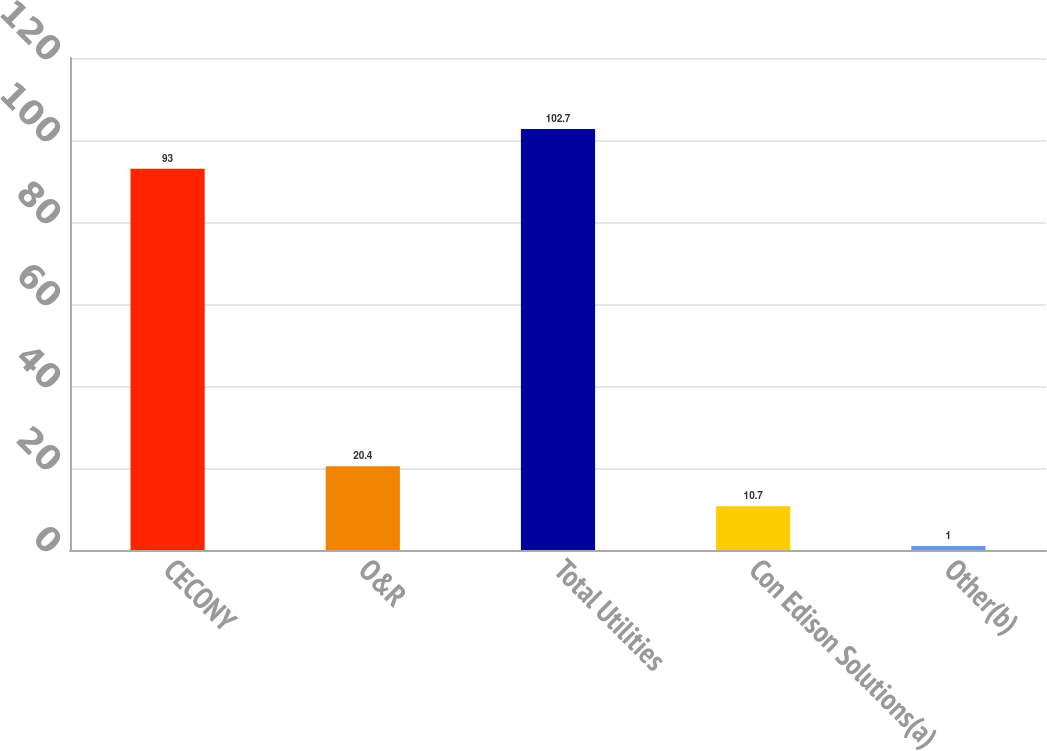Convert chart to OTSL. <chart><loc_0><loc_0><loc_500><loc_500><bar_chart><fcel>CECONY<fcel>O&R<fcel>Total Utilities<fcel>Con Edison Solutions(a)<fcel>Other(b)<nl><fcel>93<fcel>20.4<fcel>102.7<fcel>10.7<fcel>1<nl></chart> 